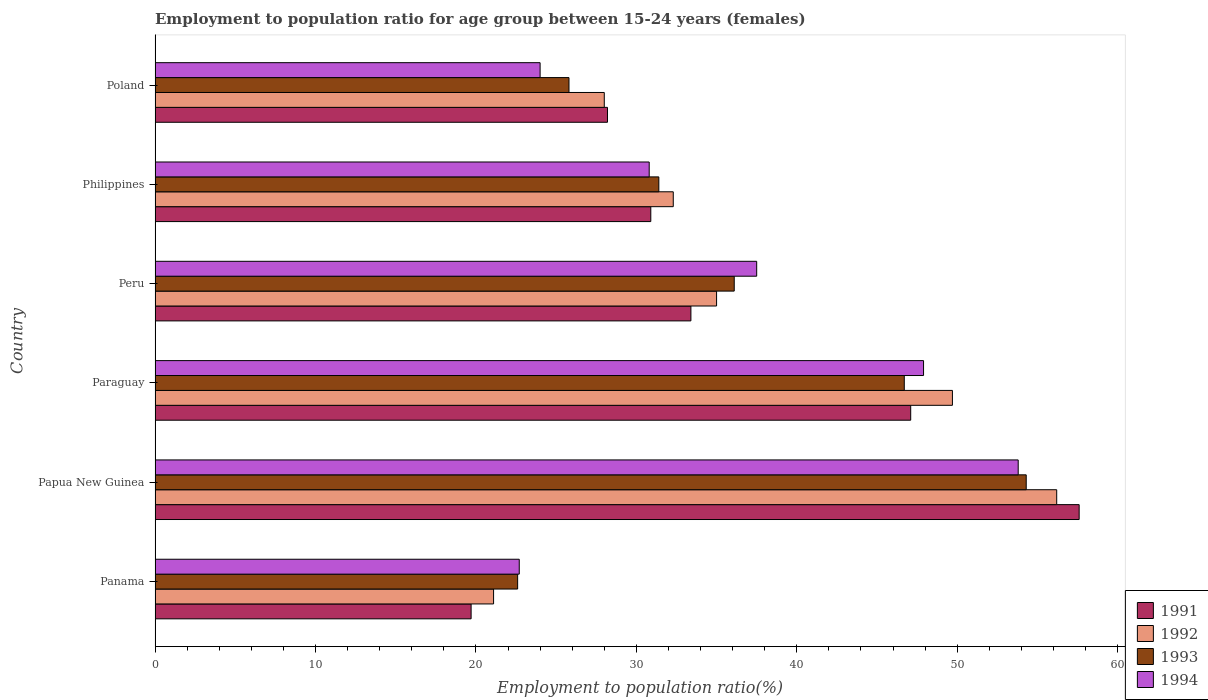How many different coloured bars are there?
Your answer should be compact. 4. How many groups of bars are there?
Offer a terse response. 6. Are the number of bars on each tick of the Y-axis equal?
Give a very brief answer. Yes. What is the label of the 2nd group of bars from the top?
Make the answer very short. Philippines. What is the employment to population ratio in 1993 in Philippines?
Ensure brevity in your answer.  31.4. Across all countries, what is the maximum employment to population ratio in 1991?
Ensure brevity in your answer.  57.6. Across all countries, what is the minimum employment to population ratio in 1994?
Your response must be concise. 22.7. In which country was the employment to population ratio in 1994 maximum?
Your response must be concise. Papua New Guinea. In which country was the employment to population ratio in 1991 minimum?
Provide a succinct answer. Panama. What is the total employment to population ratio in 1992 in the graph?
Your answer should be compact. 222.3. What is the difference between the employment to population ratio in 1993 in Philippines and that in Poland?
Ensure brevity in your answer.  5.6. What is the difference between the employment to population ratio in 1991 in Papua New Guinea and the employment to population ratio in 1993 in Panama?
Offer a very short reply. 35. What is the average employment to population ratio in 1992 per country?
Provide a short and direct response. 37.05. What is the difference between the employment to population ratio in 1992 and employment to population ratio in 1993 in Philippines?
Ensure brevity in your answer.  0.9. In how many countries, is the employment to population ratio in 1991 greater than 38 %?
Your answer should be compact. 2. What is the ratio of the employment to population ratio in 1991 in Panama to that in Paraguay?
Your answer should be very brief. 0.42. Is the employment to population ratio in 1994 in Panama less than that in Philippines?
Offer a very short reply. Yes. Is the difference between the employment to population ratio in 1992 in Paraguay and Peru greater than the difference between the employment to population ratio in 1993 in Paraguay and Peru?
Make the answer very short. Yes. What is the difference between the highest and the second highest employment to population ratio in 1992?
Your answer should be very brief. 6.5. What is the difference between the highest and the lowest employment to population ratio in 1993?
Ensure brevity in your answer.  31.7. What does the 2nd bar from the top in Poland represents?
Keep it short and to the point. 1993. What does the 4th bar from the bottom in Paraguay represents?
Provide a short and direct response. 1994. How many bars are there?
Give a very brief answer. 24. Are all the bars in the graph horizontal?
Your response must be concise. Yes. How many countries are there in the graph?
Give a very brief answer. 6. Does the graph contain any zero values?
Make the answer very short. No. Does the graph contain grids?
Offer a terse response. No. Where does the legend appear in the graph?
Ensure brevity in your answer.  Bottom right. What is the title of the graph?
Your response must be concise. Employment to population ratio for age group between 15-24 years (females). Does "2003" appear as one of the legend labels in the graph?
Provide a short and direct response. No. What is the Employment to population ratio(%) in 1991 in Panama?
Ensure brevity in your answer.  19.7. What is the Employment to population ratio(%) in 1992 in Panama?
Make the answer very short. 21.1. What is the Employment to population ratio(%) in 1993 in Panama?
Ensure brevity in your answer.  22.6. What is the Employment to population ratio(%) in 1994 in Panama?
Provide a short and direct response. 22.7. What is the Employment to population ratio(%) in 1991 in Papua New Guinea?
Your answer should be compact. 57.6. What is the Employment to population ratio(%) in 1992 in Papua New Guinea?
Your answer should be compact. 56.2. What is the Employment to population ratio(%) in 1993 in Papua New Guinea?
Give a very brief answer. 54.3. What is the Employment to population ratio(%) of 1994 in Papua New Guinea?
Ensure brevity in your answer.  53.8. What is the Employment to population ratio(%) in 1991 in Paraguay?
Keep it short and to the point. 47.1. What is the Employment to population ratio(%) in 1992 in Paraguay?
Keep it short and to the point. 49.7. What is the Employment to population ratio(%) in 1993 in Paraguay?
Your answer should be compact. 46.7. What is the Employment to population ratio(%) of 1994 in Paraguay?
Ensure brevity in your answer.  47.9. What is the Employment to population ratio(%) of 1991 in Peru?
Ensure brevity in your answer.  33.4. What is the Employment to population ratio(%) of 1992 in Peru?
Your response must be concise. 35. What is the Employment to population ratio(%) in 1993 in Peru?
Your response must be concise. 36.1. What is the Employment to population ratio(%) in 1994 in Peru?
Give a very brief answer. 37.5. What is the Employment to population ratio(%) in 1991 in Philippines?
Ensure brevity in your answer.  30.9. What is the Employment to population ratio(%) in 1992 in Philippines?
Give a very brief answer. 32.3. What is the Employment to population ratio(%) of 1993 in Philippines?
Your answer should be very brief. 31.4. What is the Employment to population ratio(%) in 1994 in Philippines?
Provide a succinct answer. 30.8. What is the Employment to population ratio(%) in 1991 in Poland?
Give a very brief answer. 28.2. What is the Employment to population ratio(%) in 1993 in Poland?
Provide a short and direct response. 25.8. Across all countries, what is the maximum Employment to population ratio(%) in 1991?
Provide a short and direct response. 57.6. Across all countries, what is the maximum Employment to population ratio(%) in 1992?
Offer a terse response. 56.2. Across all countries, what is the maximum Employment to population ratio(%) of 1993?
Offer a terse response. 54.3. Across all countries, what is the maximum Employment to population ratio(%) of 1994?
Ensure brevity in your answer.  53.8. Across all countries, what is the minimum Employment to population ratio(%) in 1991?
Ensure brevity in your answer.  19.7. Across all countries, what is the minimum Employment to population ratio(%) of 1992?
Provide a short and direct response. 21.1. Across all countries, what is the minimum Employment to population ratio(%) of 1993?
Provide a succinct answer. 22.6. Across all countries, what is the minimum Employment to population ratio(%) in 1994?
Offer a very short reply. 22.7. What is the total Employment to population ratio(%) in 1991 in the graph?
Your response must be concise. 216.9. What is the total Employment to population ratio(%) in 1992 in the graph?
Your answer should be compact. 222.3. What is the total Employment to population ratio(%) of 1993 in the graph?
Your answer should be very brief. 216.9. What is the total Employment to population ratio(%) in 1994 in the graph?
Offer a very short reply. 216.7. What is the difference between the Employment to population ratio(%) in 1991 in Panama and that in Papua New Guinea?
Provide a short and direct response. -37.9. What is the difference between the Employment to population ratio(%) in 1992 in Panama and that in Papua New Guinea?
Provide a succinct answer. -35.1. What is the difference between the Employment to population ratio(%) of 1993 in Panama and that in Papua New Guinea?
Your answer should be compact. -31.7. What is the difference between the Employment to population ratio(%) in 1994 in Panama and that in Papua New Guinea?
Keep it short and to the point. -31.1. What is the difference between the Employment to population ratio(%) of 1991 in Panama and that in Paraguay?
Your answer should be compact. -27.4. What is the difference between the Employment to population ratio(%) of 1992 in Panama and that in Paraguay?
Make the answer very short. -28.6. What is the difference between the Employment to population ratio(%) of 1993 in Panama and that in Paraguay?
Your response must be concise. -24.1. What is the difference between the Employment to population ratio(%) in 1994 in Panama and that in Paraguay?
Make the answer very short. -25.2. What is the difference between the Employment to population ratio(%) in 1991 in Panama and that in Peru?
Offer a terse response. -13.7. What is the difference between the Employment to population ratio(%) in 1992 in Panama and that in Peru?
Your response must be concise. -13.9. What is the difference between the Employment to population ratio(%) of 1993 in Panama and that in Peru?
Provide a short and direct response. -13.5. What is the difference between the Employment to population ratio(%) in 1994 in Panama and that in Peru?
Provide a short and direct response. -14.8. What is the difference between the Employment to population ratio(%) of 1992 in Panama and that in Philippines?
Provide a succinct answer. -11.2. What is the difference between the Employment to population ratio(%) of 1993 in Panama and that in Philippines?
Your answer should be very brief. -8.8. What is the difference between the Employment to population ratio(%) in 1991 in Panama and that in Poland?
Keep it short and to the point. -8.5. What is the difference between the Employment to population ratio(%) in 1993 in Papua New Guinea and that in Paraguay?
Ensure brevity in your answer.  7.6. What is the difference between the Employment to population ratio(%) of 1994 in Papua New Guinea and that in Paraguay?
Keep it short and to the point. 5.9. What is the difference between the Employment to population ratio(%) in 1991 in Papua New Guinea and that in Peru?
Provide a short and direct response. 24.2. What is the difference between the Employment to population ratio(%) in 1992 in Papua New Guinea and that in Peru?
Offer a terse response. 21.2. What is the difference between the Employment to population ratio(%) in 1993 in Papua New Guinea and that in Peru?
Provide a succinct answer. 18.2. What is the difference between the Employment to population ratio(%) of 1991 in Papua New Guinea and that in Philippines?
Make the answer very short. 26.7. What is the difference between the Employment to population ratio(%) in 1992 in Papua New Guinea and that in Philippines?
Your answer should be very brief. 23.9. What is the difference between the Employment to population ratio(%) of 1993 in Papua New Guinea and that in Philippines?
Your answer should be very brief. 22.9. What is the difference between the Employment to population ratio(%) in 1991 in Papua New Guinea and that in Poland?
Your response must be concise. 29.4. What is the difference between the Employment to population ratio(%) of 1992 in Papua New Guinea and that in Poland?
Ensure brevity in your answer.  28.2. What is the difference between the Employment to population ratio(%) of 1994 in Papua New Guinea and that in Poland?
Provide a succinct answer. 29.8. What is the difference between the Employment to population ratio(%) of 1994 in Paraguay and that in Peru?
Keep it short and to the point. 10.4. What is the difference between the Employment to population ratio(%) of 1991 in Paraguay and that in Philippines?
Your answer should be very brief. 16.2. What is the difference between the Employment to population ratio(%) in 1994 in Paraguay and that in Philippines?
Your response must be concise. 17.1. What is the difference between the Employment to population ratio(%) in 1991 in Paraguay and that in Poland?
Keep it short and to the point. 18.9. What is the difference between the Employment to population ratio(%) in 1992 in Paraguay and that in Poland?
Your response must be concise. 21.7. What is the difference between the Employment to population ratio(%) of 1993 in Paraguay and that in Poland?
Your answer should be compact. 20.9. What is the difference between the Employment to population ratio(%) of 1994 in Paraguay and that in Poland?
Offer a very short reply. 23.9. What is the difference between the Employment to population ratio(%) of 1991 in Peru and that in Philippines?
Provide a short and direct response. 2.5. What is the difference between the Employment to population ratio(%) of 1992 in Peru and that in Philippines?
Provide a short and direct response. 2.7. What is the difference between the Employment to population ratio(%) of 1994 in Peru and that in Philippines?
Provide a succinct answer. 6.7. What is the difference between the Employment to population ratio(%) of 1991 in Panama and the Employment to population ratio(%) of 1992 in Papua New Guinea?
Your answer should be very brief. -36.5. What is the difference between the Employment to population ratio(%) in 1991 in Panama and the Employment to population ratio(%) in 1993 in Papua New Guinea?
Provide a short and direct response. -34.6. What is the difference between the Employment to population ratio(%) in 1991 in Panama and the Employment to population ratio(%) in 1994 in Papua New Guinea?
Provide a succinct answer. -34.1. What is the difference between the Employment to population ratio(%) in 1992 in Panama and the Employment to population ratio(%) in 1993 in Papua New Guinea?
Ensure brevity in your answer.  -33.2. What is the difference between the Employment to population ratio(%) in 1992 in Panama and the Employment to population ratio(%) in 1994 in Papua New Guinea?
Provide a succinct answer. -32.7. What is the difference between the Employment to population ratio(%) of 1993 in Panama and the Employment to population ratio(%) of 1994 in Papua New Guinea?
Provide a succinct answer. -31.2. What is the difference between the Employment to population ratio(%) of 1991 in Panama and the Employment to population ratio(%) of 1993 in Paraguay?
Make the answer very short. -27. What is the difference between the Employment to population ratio(%) of 1991 in Panama and the Employment to population ratio(%) of 1994 in Paraguay?
Make the answer very short. -28.2. What is the difference between the Employment to population ratio(%) of 1992 in Panama and the Employment to population ratio(%) of 1993 in Paraguay?
Ensure brevity in your answer.  -25.6. What is the difference between the Employment to population ratio(%) of 1992 in Panama and the Employment to population ratio(%) of 1994 in Paraguay?
Provide a succinct answer. -26.8. What is the difference between the Employment to population ratio(%) in 1993 in Panama and the Employment to population ratio(%) in 1994 in Paraguay?
Offer a terse response. -25.3. What is the difference between the Employment to population ratio(%) of 1991 in Panama and the Employment to population ratio(%) of 1992 in Peru?
Your answer should be compact. -15.3. What is the difference between the Employment to population ratio(%) in 1991 in Panama and the Employment to population ratio(%) in 1993 in Peru?
Your answer should be compact. -16.4. What is the difference between the Employment to population ratio(%) of 1991 in Panama and the Employment to population ratio(%) of 1994 in Peru?
Offer a very short reply. -17.8. What is the difference between the Employment to population ratio(%) of 1992 in Panama and the Employment to population ratio(%) of 1993 in Peru?
Provide a short and direct response. -15. What is the difference between the Employment to population ratio(%) of 1992 in Panama and the Employment to population ratio(%) of 1994 in Peru?
Ensure brevity in your answer.  -16.4. What is the difference between the Employment to population ratio(%) of 1993 in Panama and the Employment to population ratio(%) of 1994 in Peru?
Give a very brief answer. -14.9. What is the difference between the Employment to population ratio(%) in 1991 in Panama and the Employment to population ratio(%) in 1992 in Philippines?
Give a very brief answer. -12.6. What is the difference between the Employment to population ratio(%) in 1992 in Panama and the Employment to population ratio(%) in 1993 in Philippines?
Your response must be concise. -10.3. What is the difference between the Employment to population ratio(%) of 1993 in Panama and the Employment to population ratio(%) of 1994 in Philippines?
Give a very brief answer. -8.2. What is the difference between the Employment to population ratio(%) in 1991 in Panama and the Employment to population ratio(%) in 1993 in Poland?
Offer a terse response. -6.1. What is the difference between the Employment to population ratio(%) in 1991 in Panama and the Employment to population ratio(%) in 1994 in Poland?
Provide a short and direct response. -4.3. What is the difference between the Employment to population ratio(%) in 1992 in Panama and the Employment to population ratio(%) in 1994 in Poland?
Keep it short and to the point. -2.9. What is the difference between the Employment to population ratio(%) of 1991 in Papua New Guinea and the Employment to population ratio(%) of 1993 in Paraguay?
Give a very brief answer. 10.9. What is the difference between the Employment to population ratio(%) in 1991 in Papua New Guinea and the Employment to population ratio(%) in 1994 in Paraguay?
Make the answer very short. 9.7. What is the difference between the Employment to population ratio(%) in 1992 in Papua New Guinea and the Employment to population ratio(%) in 1994 in Paraguay?
Provide a succinct answer. 8.3. What is the difference between the Employment to population ratio(%) in 1993 in Papua New Guinea and the Employment to population ratio(%) in 1994 in Paraguay?
Provide a succinct answer. 6.4. What is the difference between the Employment to population ratio(%) in 1991 in Papua New Guinea and the Employment to population ratio(%) in 1992 in Peru?
Offer a terse response. 22.6. What is the difference between the Employment to population ratio(%) in 1991 in Papua New Guinea and the Employment to population ratio(%) in 1993 in Peru?
Ensure brevity in your answer.  21.5. What is the difference between the Employment to population ratio(%) in 1991 in Papua New Guinea and the Employment to population ratio(%) in 1994 in Peru?
Provide a succinct answer. 20.1. What is the difference between the Employment to population ratio(%) in 1992 in Papua New Guinea and the Employment to population ratio(%) in 1993 in Peru?
Give a very brief answer. 20.1. What is the difference between the Employment to population ratio(%) in 1993 in Papua New Guinea and the Employment to population ratio(%) in 1994 in Peru?
Give a very brief answer. 16.8. What is the difference between the Employment to population ratio(%) of 1991 in Papua New Guinea and the Employment to population ratio(%) of 1992 in Philippines?
Make the answer very short. 25.3. What is the difference between the Employment to population ratio(%) of 1991 in Papua New Guinea and the Employment to population ratio(%) of 1993 in Philippines?
Your response must be concise. 26.2. What is the difference between the Employment to population ratio(%) in 1991 in Papua New Guinea and the Employment to population ratio(%) in 1994 in Philippines?
Provide a succinct answer. 26.8. What is the difference between the Employment to population ratio(%) in 1992 in Papua New Guinea and the Employment to population ratio(%) in 1993 in Philippines?
Offer a very short reply. 24.8. What is the difference between the Employment to population ratio(%) in 1992 in Papua New Guinea and the Employment to population ratio(%) in 1994 in Philippines?
Offer a very short reply. 25.4. What is the difference between the Employment to population ratio(%) in 1993 in Papua New Guinea and the Employment to population ratio(%) in 1994 in Philippines?
Provide a succinct answer. 23.5. What is the difference between the Employment to population ratio(%) in 1991 in Papua New Guinea and the Employment to population ratio(%) in 1992 in Poland?
Provide a short and direct response. 29.6. What is the difference between the Employment to population ratio(%) of 1991 in Papua New Guinea and the Employment to population ratio(%) of 1993 in Poland?
Your answer should be very brief. 31.8. What is the difference between the Employment to population ratio(%) in 1991 in Papua New Guinea and the Employment to population ratio(%) in 1994 in Poland?
Make the answer very short. 33.6. What is the difference between the Employment to population ratio(%) in 1992 in Papua New Guinea and the Employment to population ratio(%) in 1993 in Poland?
Your response must be concise. 30.4. What is the difference between the Employment to population ratio(%) of 1992 in Papua New Guinea and the Employment to population ratio(%) of 1994 in Poland?
Your answer should be compact. 32.2. What is the difference between the Employment to population ratio(%) in 1993 in Papua New Guinea and the Employment to population ratio(%) in 1994 in Poland?
Your response must be concise. 30.3. What is the difference between the Employment to population ratio(%) in 1991 in Paraguay and the Employment to population ratio(%) in 1992 in Peru?
Make the answer very short. 12.1. What is the difference between the Employment to population ratio(%) of 1991 in Paraguay and the Employment to population ratio(%) of 1993 in Peru?
Keep it short and to the point. 11. What is the difference between the Employment to population ratio(%) in 1991 in Paraguay and the Employment to population ratio(%) in 1994 in Peru?
Your answer should be compact. 9.6. What is the difference between the Employment to population ratio(%) of 1992 in Paraguay and the Employment to population ratio(%) of 1993 in Peru?
Ensure brevity in your answer.  13.6. What is the difference between the Employment to population ratio(%) in 1991 in Paraguay and the Employment to population ratio(%) in 1992 in Philippines?
Your answer should be compact. 14.8. What is the difference between the Employment to population ratio(%) in 1991 in Paraguay and the Employment to population ratio(%) in 1993 in Philippines?
Give a very brief answer. 15.7. What is the difference between the Employment to population ratio(%) of 1991 in Paraguay and the Employment to population ratio(%) of 1994 in Philippines?
Provide a short and direct response. 16.3. What is the difference between the Employment to population ratio(%) in 1993 in Paraguay and the Employment to population ratio(%) in 1994 in Philippines?
Make the answer very short. 15.9. What is the difference between the Employment to population ratio(%) in 1991 in Paraguay and the Employment to population ratio(%) in 1993 in Poland?
Offer a very short reply. 21.3. What is the difference between the Employment to population ratio(%) of 1991 in Paraguay and the Employment to population ratio(%) of 1994 in Poland?
Your answer should be compact. 23.1. What is the difference between the Employment to population ratio(%) of 1992 in Paraguay and the Employment to population ratio(%) of 1993 in Poland?
Make the answer very short. 23.9. What is the difference between the Employment to population ratio(%) of 1992 in Paraguay and the Employment to population ratio(%) of 1994 in Poland?
Provide a succinct answer. 25.7. What is the difference between the Employment to population ratio(%) in 1993 in Paraguay and the Employment to population ratio(%) in 1994 in Poland?
Give a very brief answer. 22.7. What is the difference between the Employment to population ratio(%) in 1991 in Peru and the Employment to population ratio(%) in 1992 in Philippines?
Make the answer very short. 1.1. What is the difference between the Employment to population ratio(%) of 1991 in Peru and the Employment to population ratio(%) of 1993 in Philippines?
Your answer should be very brief. 2. What is the difference between the Employment to population ratio(%) in 1991 in Peru and the Employment to population ratio(%) in 1994 in Philippines?
Your answer should be compact. 2.6. What is the difference between the Employment to population ratio(%) in 1992 in Peru and the Employment to population ratio(%) in 1993 in Philippines?
Make the answer very short. 3.6. What is the difference between the Employment to population ratio(%) of 1992 in Peru and the Employment to population ratio(%) of 1994 in Philippines?
Offer a very short reply. 4.2. What is the difference between the Employment to population ratio(%) of 1991 in Peru and the Employment to population ratio(%) of 1993 in Poland?
Provide a succinct answer. 7.6. What is the difference between the Employment to population ratio(%) in 1991 in Peru and the Employment to population ratio(%) in 1994 in Poland?
Your response must be concise. 9.4. What is the difference between the Employment to population ratio(%) in 1992 in Peru and the Employment to population ratio(%) in 1993 in Poland?
Your answer should be compact. 9.2. What is the difference between the Employment to population ratio(%) in 1992 in Peru and the Employment to population ratio(%) in 1994 in Poland?
Offer a very short reply. 11. What is the difference between the Employment to population ratio(%) in 1993 in Peru and the Employment to population ratio(%) in 1994 in Poland?
Make the answer very short. 12.1. What is the difference between the Employment to population ratio(%) of 1991 in Philippines and the Employment to population ratio(%) of 1992 in Poland?
Your answer should be compact. 2.9. What is the difference between the Employment to population ratio(%) in 1991 in Philippines and the Employment to population ratio(%) in 1993 in Poland?
Ensure brevity in your answer.  5.1. What is the difference between the Employment to population ratio(%) of 1991 in Philippines and the Employment to population ratio(%) of 1994 in Poland?
Offer a terse response. 6.9. What is the difference between the Employment to population ratio(%) in 1992 in Philippines and the Employment to population ratio(%) in 1993 in Poland?
Provide a succinct answer. 6.5. What is the difference between the Employment to population ratio(%) of 1992 in Philippines and the Employment to population ratio(%) of 1994 in Poland?
Provide a short and direct response. 8.3. What is the average Employment to population ratio(%) of 1991 per country?
Ensure brevity in your answer.  36.15. What is the average Employment to population ratio(%) of 1992 per country?
Provide a short and direct response. 37.05. What is the average Employment to population ratio(%) in 1993 per country?
Provide a succinct answer. 36.15. What is the average Employment to population ratio(%) of 1994 per country?
Your response must be concise. 36.12. What is the difference between the Employment to population ratio(%) of 1991 and Employment to population ratio(%) of 1993 in Panama?
Provide a succinct answer. -2.9. What is the difference between the Employment to population ratio(%) of 1992 and Employment to population ratio(%) of 1993 in Panama?
Offer a very short reply. -1.5. What is the difference between the Employment to population ratio(%) of 1992 and Employment to population ratio(%) of 1994 in Panama?
Provide a short and direct response. -1.6. What is the difference between the Employment to population ratio(%) of 1993 and Employment to population ratio(%) of 1994 in Panama?
Provide a short and direct response. -0.1. What is the difference between the Employment to population ratio(%) in 1991 and Employment to population ratio(%) in 1992 in Papua New Guinea?
Offer a terse response. 1.4. What is the difference between the Employment to population ratio(%) in 1991 and Employment to population ratio(%) in 1993 in Papua New Guinea?
Offer a terse response. 3.3. What is the difference between the Employment to population ratio(%) of 1991 and Employment to population ratio(%) of 1994 in Papua New Guinea?
Offer a terse response. 3.8. What is the difference between the Employment to population ratio(%) in 1992 and Employment to population ratio(%) in 1994 in Papua New Guinea?
Provide a succinct answer. 2.4. What is the difference between the Employment to population ratio(%) of 1993 and Employment to population ratio(%) of 1994 in Papua New Guinea?
Provide a short and direct response. 0.5. What is the difference between the Employment to population ratio(%) in 1991 and Employment to population ratio(%) in 1992 in Paraguay?
Your answer should be very brief. -2.6. What is the difference between the Employment to population ratio(%) in 1992 and Employment to population ratio(%) in 1993 in Paraguay?
Your response must be concise. 3. What is the difference between the Employment to population ratio(%) in 1992 and Employment to population ratio(%) in 1994 in Paraguay?
Your answer should be very brief. 1.8. What is the difference between the Employment to population ratio(%) of 1993 and Employment to population ratio(%) of 1994 in Paraguay?
Ensure brevity in your answer.  -1.2. What is the difference between the Employment to population ratio(%) in 1992 and Employment to population ratio(%) in 1993 in Peru?
Make the answer very short. -1.1. What is the difference between the Employment to population ratio(%) of 1993 and Employment to population ratio(%) of 1994 in Peru?
Your response must be concise. -1.4. What is the difference between the Employment to population ratio(%) of 1991 and Employment to population ratio(%) of 1992 in Philippines?
Keep it short and to the point. -1.4. What is the difference between the Employment to population ratio(%) of 1991 and Employment to population ratio(%) of 1994 in Philippines?
Your answer should be very brief. 0.1. What is the difference between the Employment to population ratio(%) in 1992 and Employment to population ratio(%) in 1994 in Philippines?
Your answer should be very brief. 1.5. What is the difference between the Employment to population ratio(%) in 1991 and Employment to population ratio(%) in 1993 in Poland?
Your answer should be compact. 2.4. What is the difference between the Employment to population ratio(%) in 1992 and Employment to population ratio(%) in 1993 in Poland?
Ensure brevity in your answer.  2.2. What is the difference between the Employment to population ratio(%) of 1993 and Employment to population ratio(%) of 1994 in Poland?
Keep it short and to the point. 1.8. What is the ratio of the Employment to population ratio(%) of 1991 in Panama to that in Papua New Guinea?
Your response must be concise. 0.34. What is the ratio of the Employment to population ratio(%) in 1992 in Panama to that in Papua New Guinea?
Your answer should be very brief. 0.38. What is the ratio of the Employment to population ratio(%) in 1993 in Panama to that in Papua New Guinea?
Give a very brief answer. 0.42. What is the ratio of the Employment to population ratio(%) of 1994 in Panama to that in Papua New Guinea?
Offer a very short reply. 0.42. What is the ratio of the Employment to population ratio(%) of 1991 in Panama to that in Paraguay?
Provide a short and direct response. 0.42. What is the ratio of the Employment to population ratio(%) of 1992 in Panama to that in Paraguay?
Provide a short and direct response. 0.42. What is the ratio of the Employment to population ratio(%) of 1993 in Panama to that in Paraguay?
Your response must be concise. 0.48. What is the ratio of the Employment to population ratio(%) in 1994 in Panama to that in Paraguay?
Provide a succinct answer. 0.47. What is the ratio of the Employment to population ratio(%) in 1991 in Panama to that in Peru?
Offer a terse response. 0.59. What is the ratio of the Employment to population ratio(%) in 1992 in Panama to that in Peru?
Offer a very short reply. 0.6. What is the ratio of the Employment to population ratio(%) in 1993 in Panama to that in Peru?
Your answer should be compact. 0.63. What is the ratio of the Employment to population ratio(%) in 1994 in Panama to that in Peru?
Offer a terse response. 0.61. What is the ratio of the Employment to population ratio(%) in 1991 in Panama to that in Philippines?
Provide a short and direct response. 0.64. What is the ratio of the Employment to population ratio(%) in 1992 in Panama to that in Philippines?
Your answer should be very brief. 0.65. What is the ratio of the Employment to population ratio(%) of 1993 in Panama to that in Philippines?
Ensure brevity in your answer.  0.72. What is the ratio of the Employment to population ratio(%) of 1994 in Panama to that in Philippines?
Offer a terse response. 0.74. What is the ratio of the Employment to population ratio(%) of 1991 in Panama to that in Poland?
Make the answer very short. 0.7. What is the ratio of the Employment to population ratio(%) in 1992 in Panama to that in Poland?
Ensure brevity in your answer.  0.75. What is the ratio of the Employment to population ratio(%) of 1993 in Panama to that in Poland?
Your answer should be very brief. 0.88. What is the ratio of the Employment to population ratio(%) of 1994 in Panama to that in Poland?
Ensure brevity in your answer.  0.95. What is the ratio of the Employment to population ratio(%) in 1991 in Papua New Guinea to that in Paraguay?
Provide a succinct answer. 1.22. What is the ratio of the Employment to population ratio(%) of 1992 in Papua New Guinea to that in Paraguay?
Make the answer very short. 1.13. What is the ratio of the Employment to population ratio(%) in 1993 in Papua New Guinea to that in Paraguay?
Your answer should be compact. 1.16. What is the ratio of the Employment to population ratio(%) of 1994 in Papua New Guinea to that in Paraguay?
Your response must be concise. 1.12. What is the ratio of the Employment to population ratio(%) of 1991 in Papua New Guinea to that in Peru?
Offer a very short reply. 1.72. What is the ratio of the Employment to population ratio(%) in 1992 in Papua New Guinea to that in Peru?
Make the answer very short. 1.61. What is the ratio of the Employment to population ratio(%) in 1993 in Papua New Guinea to that in Peru?
Provide a short and direct response. 1.5. What is the ratio of the Employment to population ratio(%) of 1994 in Papua New Guinea to that in Peru?
Ensure brevity in your answer.  1.43. What is the ratio of the Employment to population ratio(%) in 1991 in Papua New Guinea to that in Philippines?
Keep it short and to the point. 1.86. What is the ratio of the Employment to population ratio(%) in 1992 in Papua New Guinea to that in Philippines?
Provide a short and direct response. 1.74. What is the ratio of the Employment to population ratio(%) in 1993 in Papua New Guinea to that in Philippines?
Your answer should be compact. 1.73. What is the ratio of the Employment to population ratio(%) in 1994 in Papua New Guinea to that in Philippines?
Make the answer very short. 1.75. What is the ratio of the Employment to population ratio(%) of 1991 in Papua New Guinea to that in Poland?
Keep it short and to the point. 2.04. What is the ratio of the Employment to population ratio(%) in 1992 in Papua New Guinea to that in Poland?
Offer a terse response. 2.01. What is the ratio of the Employment to population ratio(%) in 1993 in Papua New Guinea to that in Poland?
Your response must be concise. 2.1. What is the ratio of the Employment to population ratio(%) in 1994 in Papua New Guinea to that in Poland?
Offer a terse response. 2.24. What is the ratio of the Employment to population ratio(%) in 1991 in Paraguay to that in Peru?
Offer a very short reply. 1.41. What is the ratio of the Employment to population ratio(%) of 1992 in Paraguay to that in Peru?
Keep it short and to the point. 1.42. What is the ratio of the Employment to population ratio(%) in 1993 in Paraguay to that in Peru?
Offer a terse response. 1.29. What is the ratio of the Employment to population ratio(%) in 1994 in Paraguay to that in Peru?
Offer a terse response. 1.28. What is the ratio of the Employment to population ratio(%) in 1991 in Paraguay to that in Philippines?
Your response must be concise. 1.52. What is the ratio of the Employment to population ratio(%) in 1992 in Paraguay to that in Philippines?
Offer a very short reply. 1.54. What is the ratio of the Employment to population ratio(%) of 1993 in Paraguay to that in Philippines?
Your answer should be very brief. 1.49. What is the ratio of the Employment to population ratio(%) of 1994 in Paraguay to that in Philippines?
Provide a short and direct response. 1.56. What is the ratio of the Employment to population ratio(%) in 1991 in Paraguay to that in Poland?
Provide a short and direct response. 1.67. What is the ratio of the Employment to population ratio(%) in 1992 in Paraguay to that in Poland?
Offer a very short reply. 1.77. What is the ratio of the Employment to population ratio(%) in 1993 in Paraguay to that in Poland?
Make the answer very short. 1.81. What is the ratio of the Employment to population ratio(%) of 1994 in Paraguay to that in Poland?
Keep it short and to the point. 2. What is the ratio of the Employment to population ratio(%) in 1991 in Peru to that in Philippines?
Keep it short and to the point. 1.08. What is the ratio of the Employment to population ratio(%) of 1992 in Peru to that in Philippines?
Make the answer very short. 1.08. What is the ratio of the Employment to population ratio(%) in 1993 in Peru to that in Philippines?
Your response must be concise. 1.15. What is the ratio of the Employment to population ratio(%) in 1994 in Peru to that in Philippines?
Give a very brief answer. 1.22. What is the ratio of the Employment to population ratio(%) in 1991 in Peru to that in Poland?
Your response must be concise. 1.18. What is the ratio of the Employment to population ratio(%) in 1993 in Peru to that in Poland?
Offer a very short reply. 1.4. What is the ratio of the Employment to population ratio(%) of 1994 in Peru to that in Poland?
Keep it short and to the point. 1.56. What is the ratio of the Employment to population ratio(%) of 1991 in Philippines to that in Poland?
Ensure brevity in your answer.  1.1. What is the ratio of the Employment to population ratio(%) in 1992 in Philippines to that in Poland?
Your response must be concise. 1.15. What is the ratio of the Employment to population ratio(%) in 1993 in Philippines to that in Poland?
Give a very brief answer. 1.22. What is the ratio of the Employment to population ratio(%) of 1994 in Philippines to that in Poland?
Keep it short and to the point. 1.28. What is the difference between the highest and the second highest Employment to population ratio(%) in 1992?
Offer a terse response. 6.5. What is the difference between the highest and the lowest Employment to population ratio(%) of 1991?
Provide a short and direct response. 37.9. What is the difference between the highest and the lowest Employment to population ratio(%) in 1992?
Your answer should be very brief. 35.1. What is the difference between the highest and the lowest Employment to population ratio(%) in 1993?
Provide a short and direct response. 31.7. What is the difference between the highest and the lowest Employment to population ratio(%) in 1994?
Ensure brevity in your answer.  31.1. 